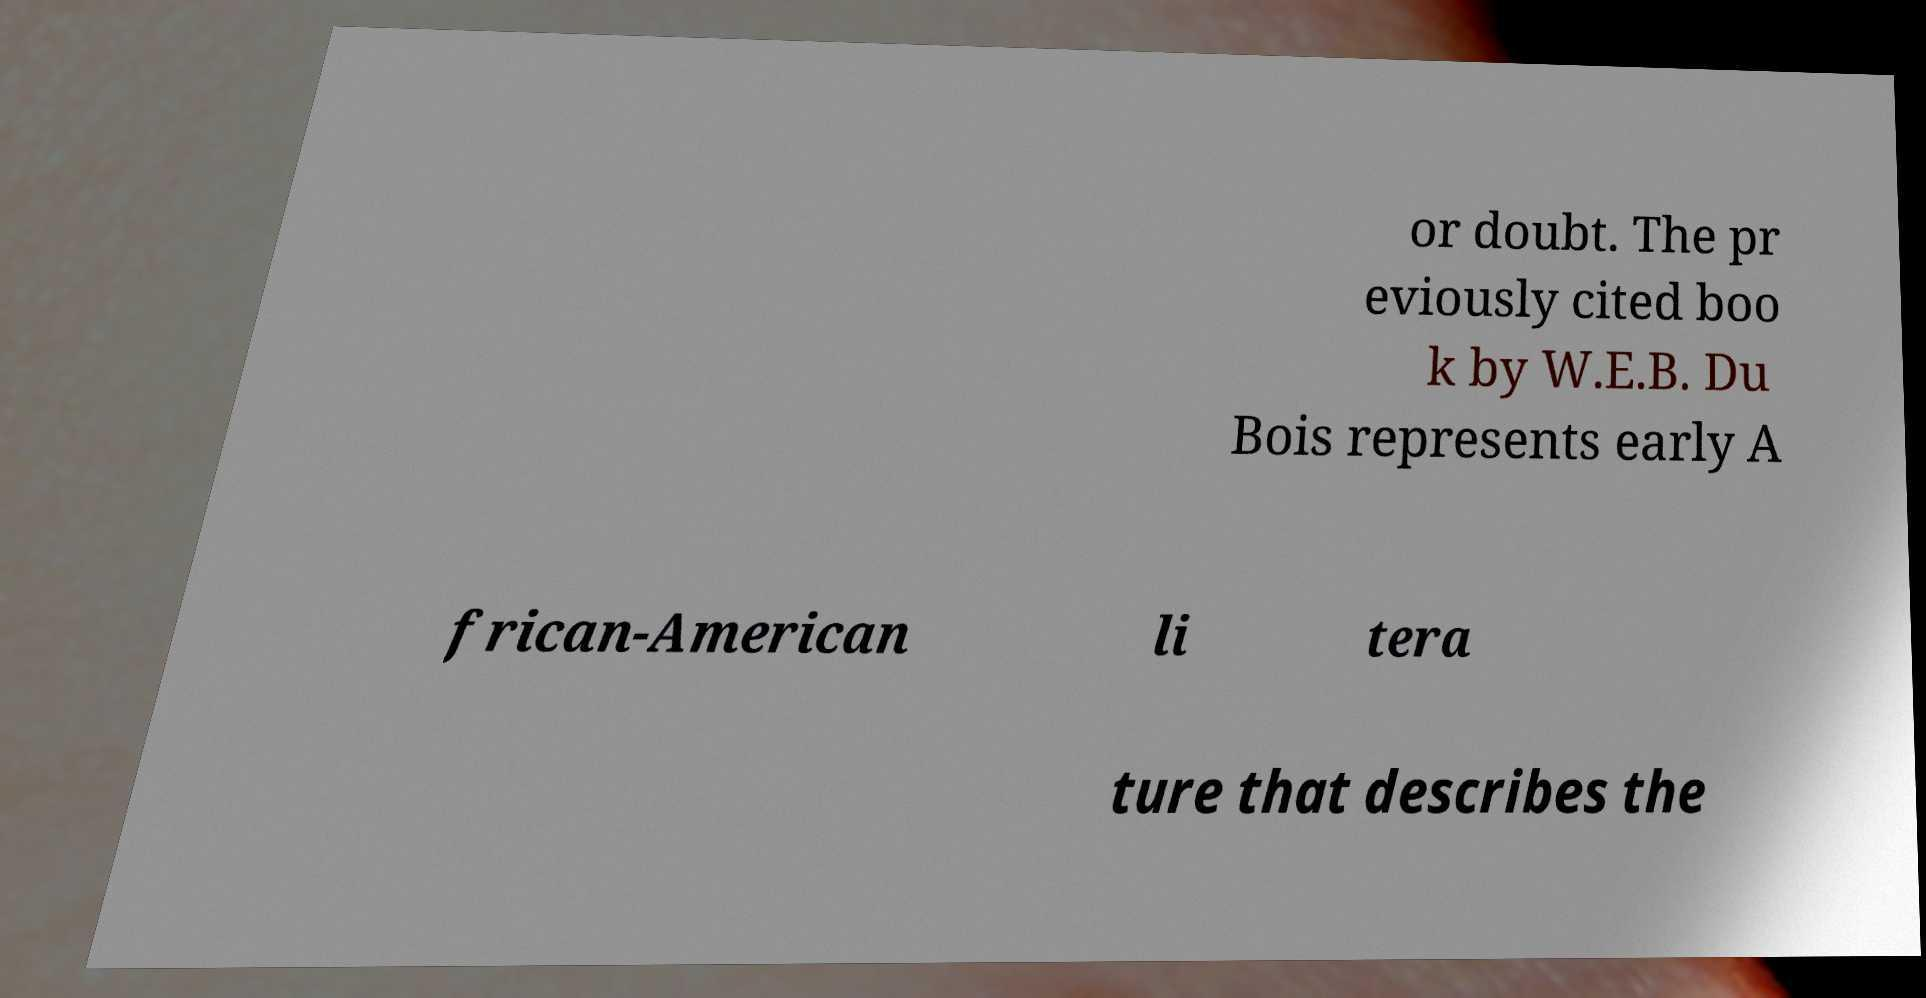Could you assist in decoding the text presented in this image and type it out clearly? or doubt. The pr eviously cited boo k by W.E.B. Du Bois represents early A frican-American li tera ture that describes the 